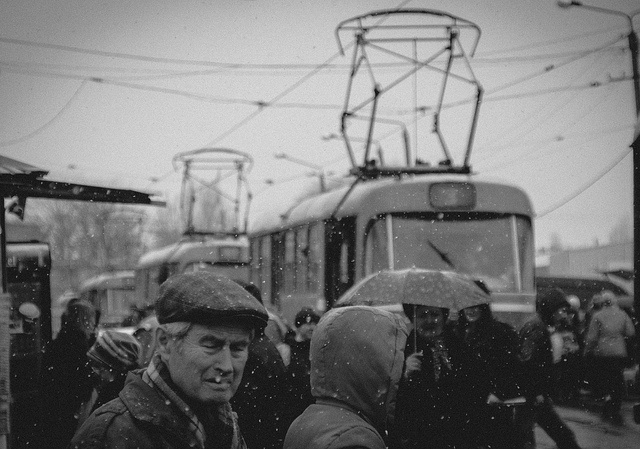Describe the objects in this image and their specific colors. I can see bus in gray, black, darkgray, and lightgray tones, people in gray and black tones, people in gray, black, and darkgray tones, people in gray, black, and lightgray tones, and people in black and gray tones in this image. 